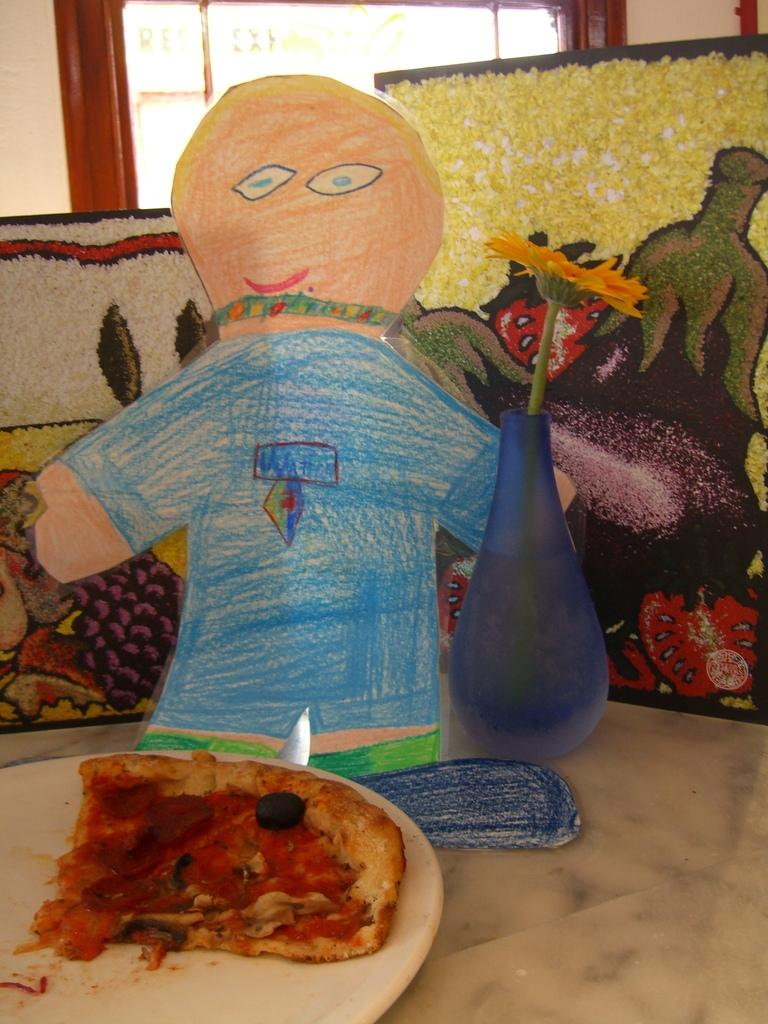What object is present on which food is placed in the image? There is a plate in the image on which a food item is placed. What type of food item can be seen on the plate? The fact does not specify the type of food item, so we cannot determine that from the information provided. What kind of plant is in a pot in the image? There is a flower in a pot in the image. What type of decorative items are present in the image? There are posters in the image. Can you tell me how many cards are being used to build a brick wall in the image? There is no mention of cards or a brick wall in the image; it features a plate with a food item, a flower in a pot, and posters. 